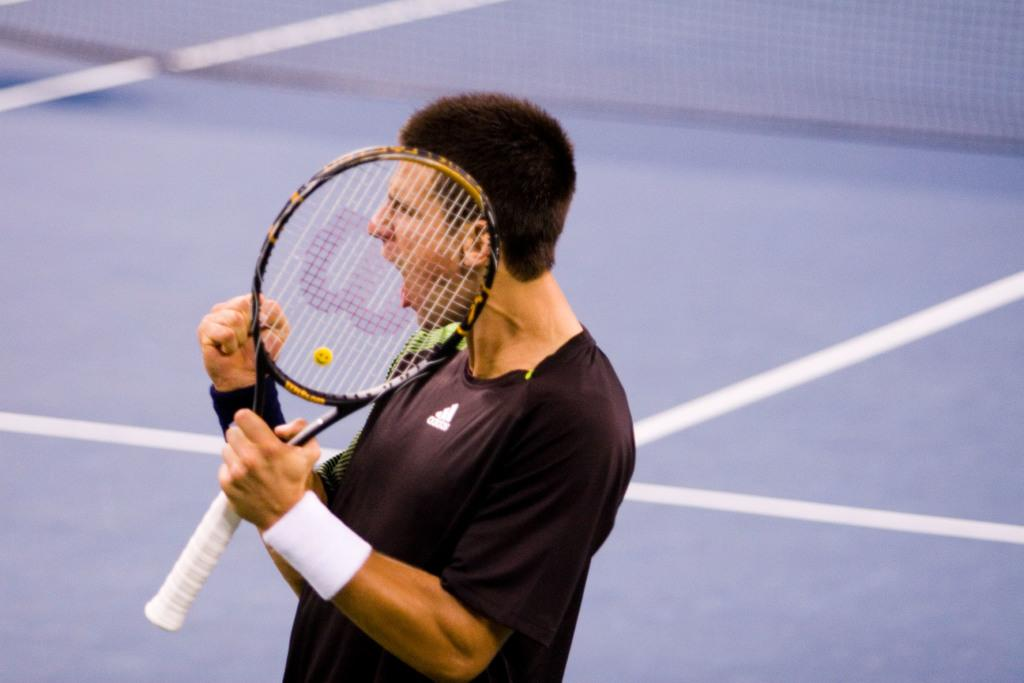What is the main subject of the image? There is a person standing in the center of the image. What is the person holding in the image? The person is holding a racket. What can be seen in the background of the image? There is a net visible in the background of the image. What type of plants are growing in the pail next to the person in the image? There is no pail or plants present in the image. What is the person's opinion about the game they are playing in the image? The image does not provide any information about the person's opinion or the game they are playing. 